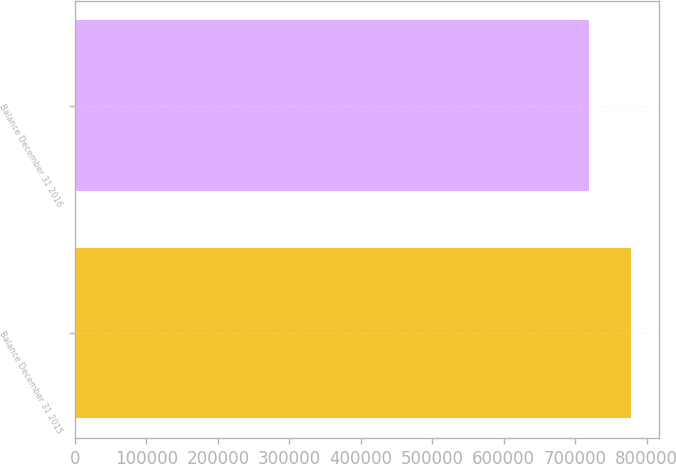<chart> <loc_0><loc_0><loc_500><loc_500><bar_chart><fcel>Balance December 31 2015<fcel>Balance December 31 2016<nl><fcel>778483<fcel>719977<nl></chart> 